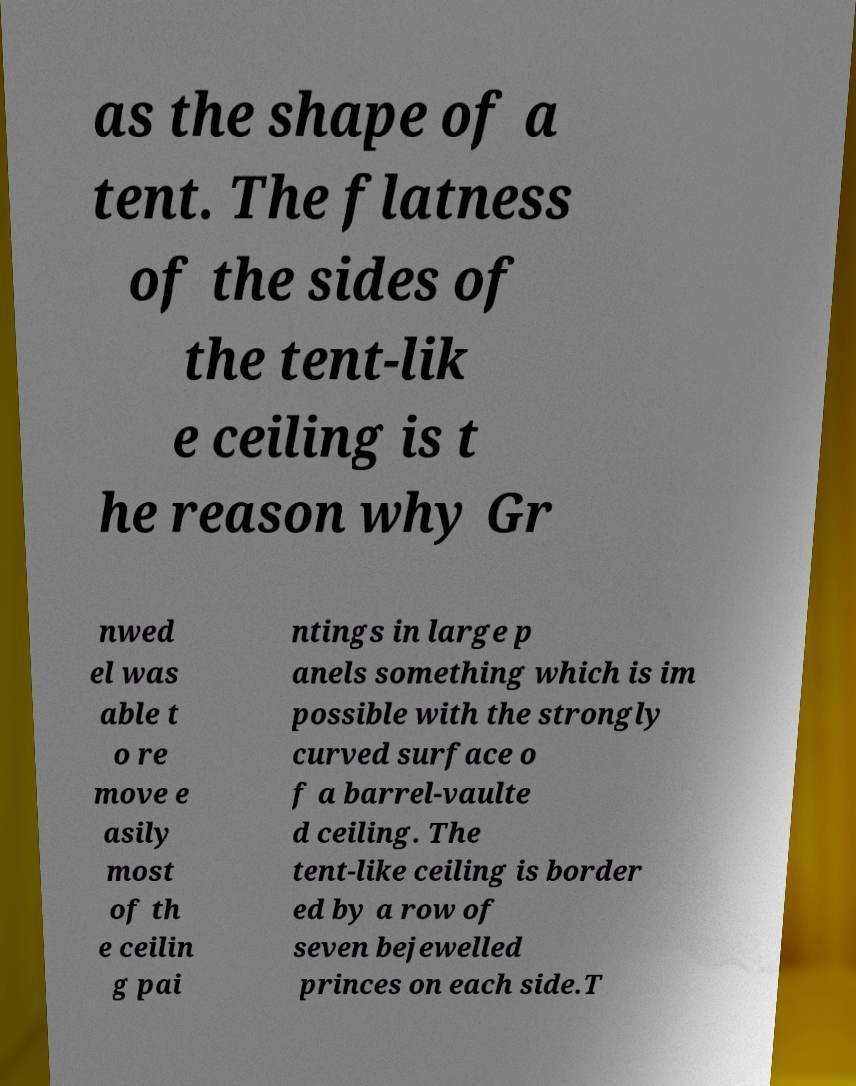What messages or text are displayed in this image? I need them in a readable, typed format. as the shape of a tent. The flatness of the sides of the tent-lik e ceiling is t he reason why Gr nwed el was able t o re move e asily most of th e ceilin g pai ntings in large p anels something which is im possible with the strongly curved surface o f a barrel-vaulte d ceiling. The tent-like ceiling is border ed by a row of seven bejewelled princes on each side.T 